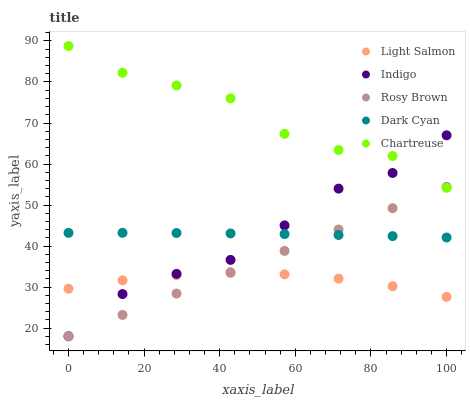Does Light Salmon have the minimum area under the curve?
Answer yes or no. Yes. Does Chartreuse have the maximum area under the curve?
Answer yes or no. Yes. Does Rosy Brown have the minimum area under the curve?
Answer yes or no. No. Does Rosy Brown have the maximum area under the curve?
Answer yes or no. No. Is Rosy Brown the smoothest?
Answer yes or no. Yes. Is Indigo the roughest?
Answer yes or no. Yes. Is Light Salmon the smoothest?
Answer yes or no. No. Is Light Salmon the roughest?
Answer yes or no. No. Does Rosy Brown have the lowest value?
Answer yes or no. Yes. Does Light Salmon have the lowest value?
Answer yes or no. No. Does Chartreuse have the highest value?
Answer yes or no. Yes. Does Rosy Brown have the highest value?
Answer yes or no. No. Is Light Salmon less than Dark Cyan?
Answer yes or no. Yes. Is Dark Cyan greater than Light Salmon?
Answer yes or no. Yes. Does Rosy Brown intersect Dark Cyan?
Answer yes or no. Yes. Is Rosy Brown less than Dark Cyan?
Answer yes or no. No. Is Rosy Brown greater than Dark Cyan?
Answer yes or no. No. Does Light Salmon intersect Dark Cyan?
Answer yes or no. No. 